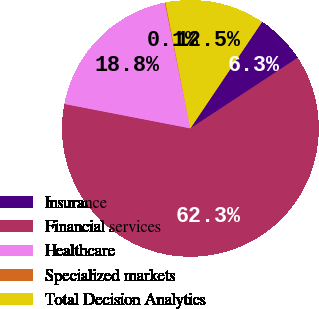Convert chart to OTSL. <chart><loc_0><loc_0><loc_500><loc_500><pie_chart><fcel>Insurance<fcel>Financial services<fcel>Healthcare<fcel>Specialized markets<fcel>Total Decision Analytics<nl><fcel>6.31%<fcel>62.31%<fcel>18.76%<fcel>0.09%<fcel>12.53%<nl></chart> 